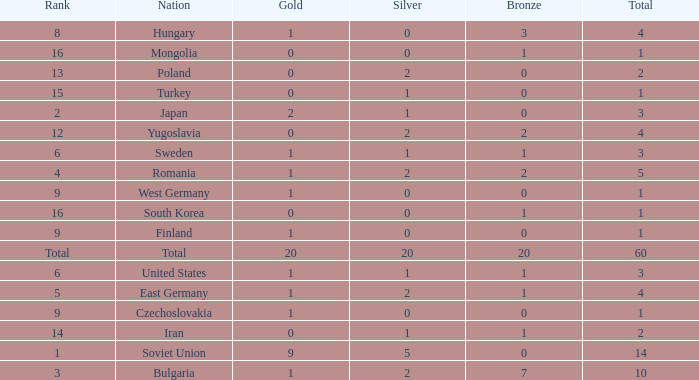What is the number of totals that have silvers under 2, bronzes over 0, and golds over 1? 0.0. 